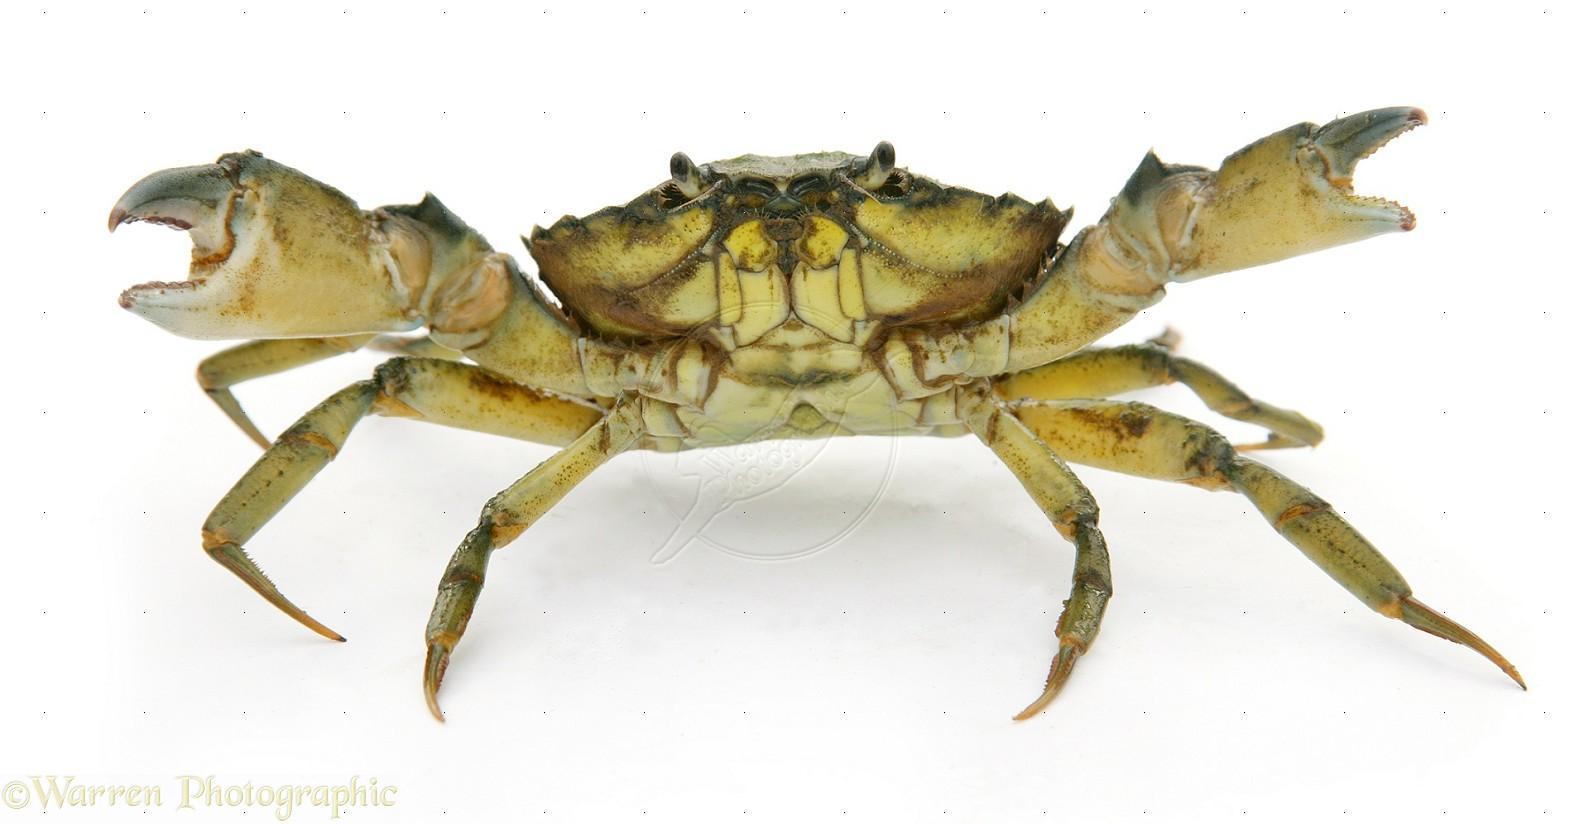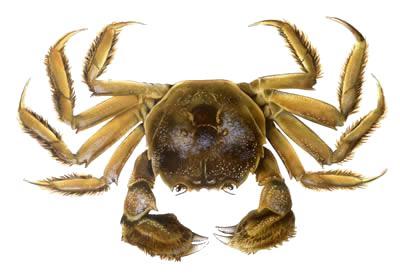The first image is the image on the left, the second image is the image on the right. Examine the images to the left and right. Is the description "there are two cooked crabs in the image pair" accurate? Answer yes or no. No. The first image is the image on the left, the second image is the image on the right. For the images shown, is this caption "Both crabs are orange." true? Answer yes or no. No. 